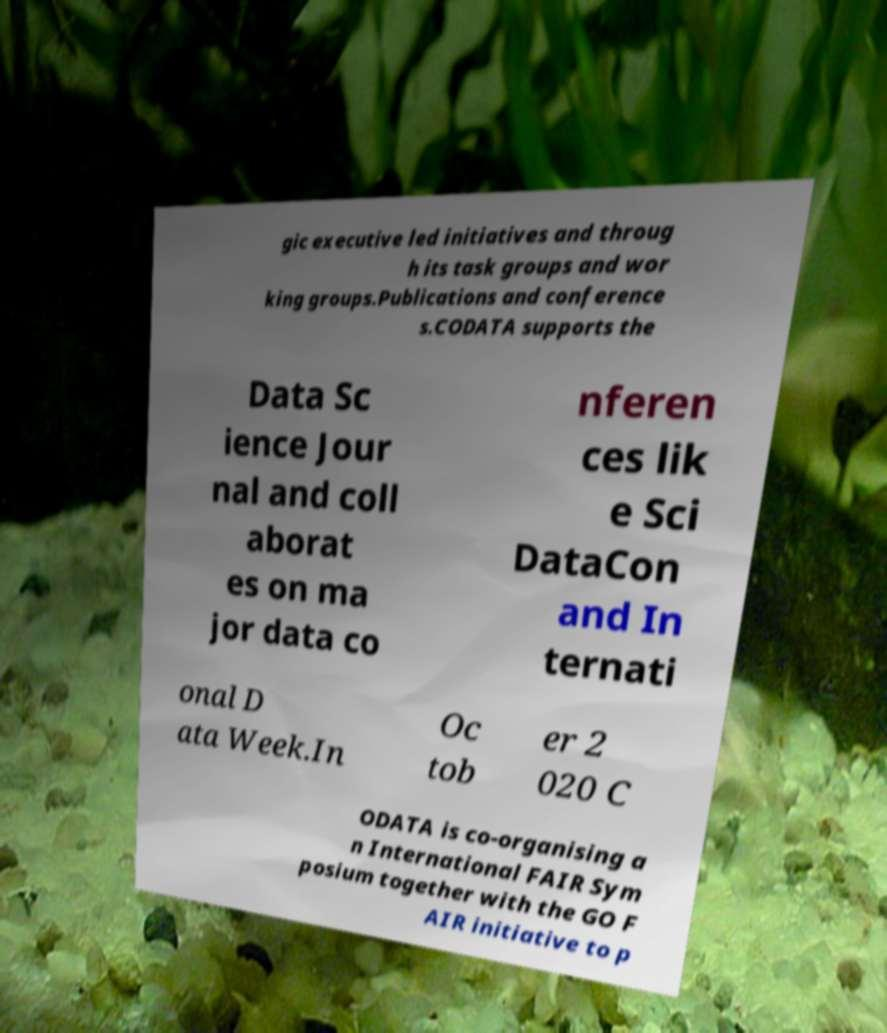What messages or text are displayed in this image? I need them in a readable, typed format. gic executive led initiatives and throug h its task groups and wor king groups.Publications and conference s.CODATA supports the Data Sc ience Jour nal and coll aborat es on ma jor data co nferen ces lik e Sci DataCon and In ternati onal D ata Week.In Oc tob er 2 020 C ODATA is co-organising a n International FAIR Sym posium together with the GO F AIR initiative to p 